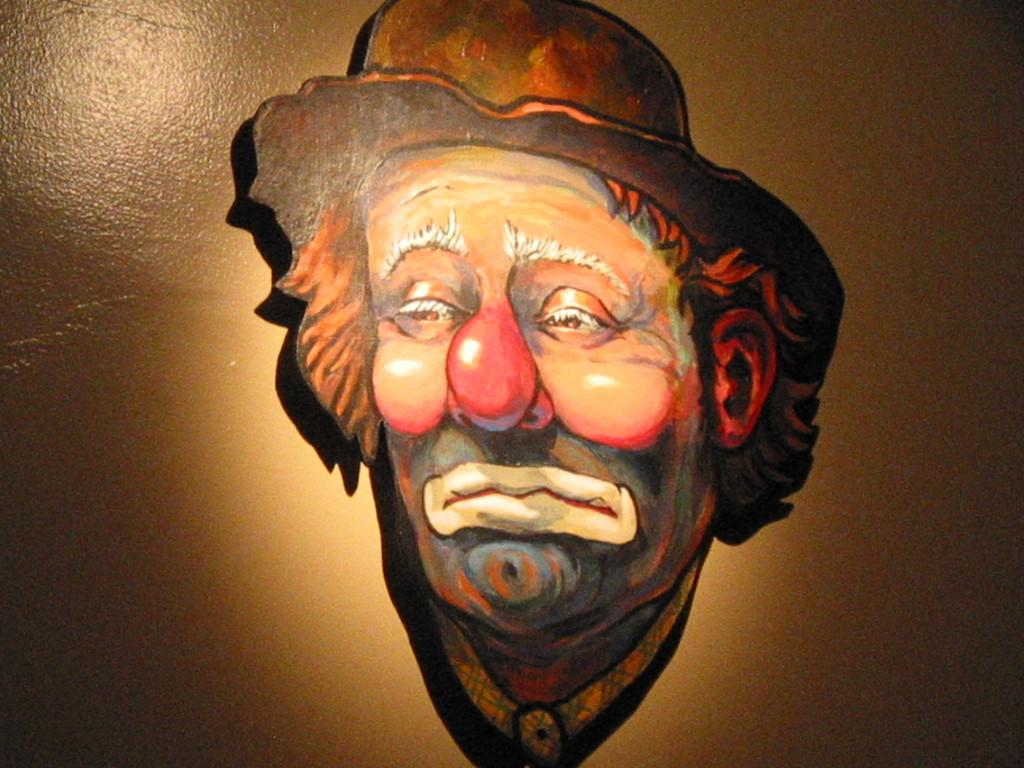What object is present in the image that is typically used for disguise or performance? There is a mask in the image. Where is the mask located in the image? The mask is attached to the wall. What time does the band start playing in the image? There is no band present in the image, so it is not possible to determine when they might start playing. 